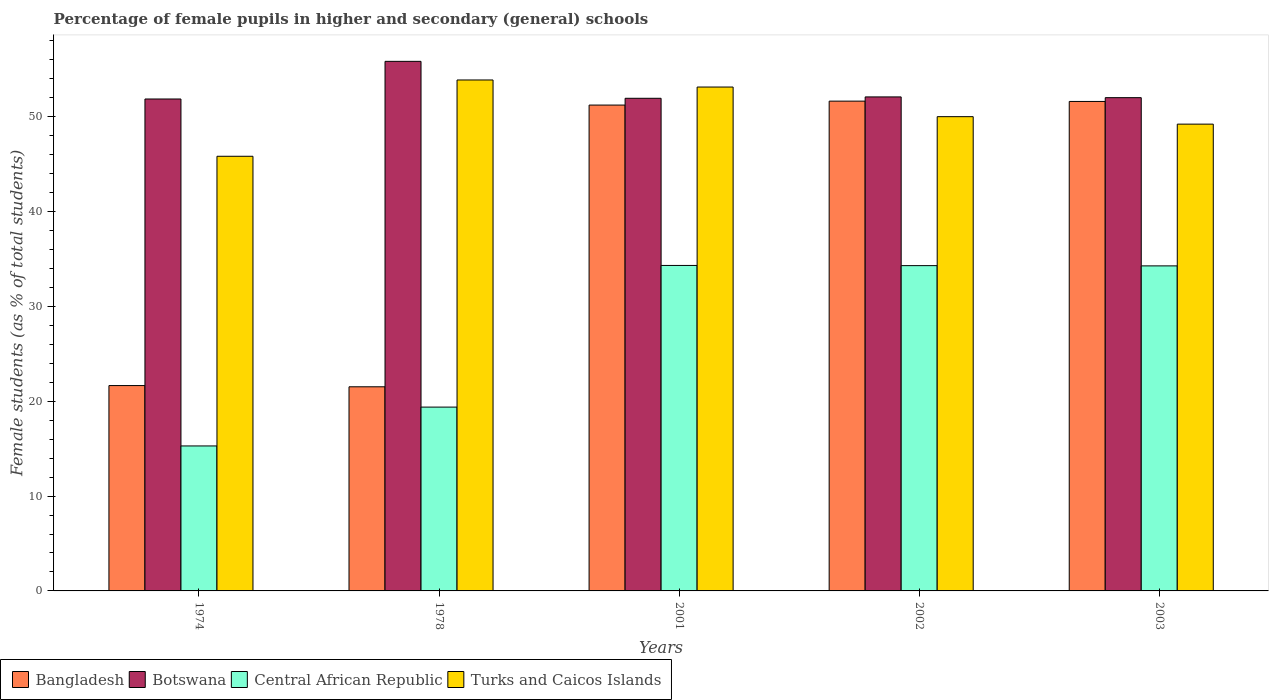Are the number of bars on each tick of the X-axis equal?
Make the answer very short. Yes. How many bars are there on the 2nd tick from the left?
Make the answer very short. 4. What is the label of the 4th group of bars from the left?
Provide a short and direct response. 2002. In how many cases, is the number of bars for a given year not equal to the number of legend labels?
Provide a short and direct response. 0. What is the percentage of female pupils in higher and secondary schools in Central African Republic in 1978?
Give a very brief answer. 19.38. Across all years, what is the maximum percentage of female pupils in higher and secondary schools in Turks and Caicos Islands?
Your response must be concise. 53.87. Across all years, what is the minimum percentage of female pupils in higher and secondary schools in Turks and Caicos Islands?
Keep it short and to the point. 45.82. In which year was the percentage of female pupils in higher and secondary schools in Bangladesh maximum?
Ensure brevity in your answer.  2002. In which year was the percentage of female pupils in higher and secondary schools in Bangladesh minimum?
Offer a terse response. 1978. What is the total percentage of female pupils in higher and secondary schools in Turks and Caicos Islands in the graph?
Offer a terse response. 252.03. What is the difference between the percentage of female pupils in higher and secondary schools in Turks and Caicos Islands in 2001 and that in 2002?
Your answer should be compact. 3.12. What is the difference between the percentage of female pupils in higher and secondary schools in Turks and Caicos Islands in 2003 and the percentage of female pupils in higher and secondary schools in Bangladesh in 1978?
Make the answer very short. 27.69. What is the average percentage of female pupils in higher and secondary schools in Central African Republic per year?
Keep it short and to the point. 27.51. In the year 2002, what is the difference between the percentage of female pupils in higher and secondary schools in Central African Republic and percentage of female pupils in higher and secondary schools in Turks and Caicos Islands?
Your answer should be compact. -15.71. What is the ratio of the percentage of female pupils in higher and secondary schools in Central African Republic in 1974 to that in 2002?
Give a very brief answer. 0.45. What is the difference between the highest and the second highest percentage of female pupils in higher and secondary schools in Bangladesh?
Offer a terse response. 0.03. What is the difference between the highest and the lowest percentage of female pupils in higher and secondary schools in Central African Republic?
Provide a succinct answer. 19.03. Is it the case that in every year, the sum of the percentage of female pupils in higher and secondary schools in Turks and Caicos Islands and percentage of female pupils in higher and secondary schools in Botswana is greater than the sum of percentage of female pupils in higher and secondary schools in Bangladesh and percentage of female pupils in higher and secondary schools in Central African Republic?
Give a very brief answer. No. What does the 2nd bar from the left in 2002 represents?
Your response must be concise. Botswana. What does the 2nd bar from the right in 2002 represents?
Offer a very short reply. Central African Republic. How many years are there in the graph?
Provide a succinct answer. 5. What is the difference between two consecutive major ticks on the Y-axis?
Your answer should be compact. 10. Does the graph contain any zero values?
Provide a short and direct response. No. Where does the legend appear in the graph?
Your answer should be compact. Bottom left. How many legend labels are there?
Provide a short and direct response. 4. What is the title of the graph?
Ensure brevity in your answer.  Percentage of female pupils in higher and secondary (general) schools. Does "Hungary" appear as one of the legend labels in the graph?
Keep it short and to the point. No. What is the label or title of the X-axis?
Provide a succinct answer. Years. What is the label or title of the Y-axis?
Offer a terse response. Female students (as % of total students). What is the Female students (as % of total students) in Bangladesh in 1974?
Offer a very short reply. 21.65. What is the Female students (as % of total students) in Botswana in 1974?
Keep it short and to the point. 51.86. What is the Female students (as % of total students) of Central African Republic in 1974?
Provide a succinct answer. 15.28. What is the Female students (as % of total students) of Turks and Caicos Islands in 1974?
Provide a succinct answer. 45.82. What is the Female students (as % of total students) in Bangladesh in 1978?
Your answer should be compact. 21.52. What is the Female students (as % of total students) of Botswana in 1978?
Make the answer very short. 55.83. What is the Female students (as % of total students) in Central African Republic in 1978?
Ensure brevity in your answer.  19.38. What is the Female students (as % of total students) of Turks and Caicos Islands in 1978?
Your answer should be compact. 53.87. What is the Female students (as % of total students) in Bangladesh in 2001?
Your response must be concise. 51.22. What is the Female students (as % of total students) of Botswana in 2001?
Your answer should be very brief. 51.94. What is the Female students (as % of total students) of Central African Republic in 2001?
Give a very brief answer. 34.31. What is the Female students (as % of total students) in Turks and Caicos Islands in 2001?
Your answer should be very brief. 53.12. What is the Female students (as % of total students) of Bangladesh in 2002?
Ensure brevity in your answer.  51.64. What is the Female students (as % of total students) of Botswana in 2002?
Provide a short and direct response. 52.08. What is the Female students (as % of total students) of Central African Republic in 2002?
Make the answer very short. 34.29. What is the Female students (as % of total students) of Bangladesh in 2003?
Keep it short and to the point. 51.6. What is the Female students (as % of total students) of Botswana in 2003?
Keep it short and to the point. 52. What is the Female students (as % of total students) of Central African Republic in 2003?
Provide a short and direct response. 34.27. What is the Female students (as % of total students) of Turks and Caicos Islands in 2003?
Your answer should be very brief. 49.21. Across all years, what is the maximum Female students (as % of total students) of Bangladesh?
Offer a terse response. 51.64. Across all years, what is the maximum Female students (as % of total students) of Botswana?
Provide a short and direct response. 55.83. Across all years, what is the maximum Female students (as % of total students) of Central African Republic?
Your response must be concise. 34.31. Across all years, what is the maximum Female students (as % of total students) in Turks and Caicos Islands?
Offer a very short reply. 53.87. Across all years, what is the minimum Female students (as % of total students) of Bangladesh?
Give a very brief answer. 21.52. Across all years, what is the minimum Female students (as % of total students) of Botswana?
Your response must be concise. 51.86. Across all years, what is the minimum Female students (as % of total students) of Central African Republic?
Your answer should be very brief. 15.28. Across all years, what is the minimum Female students (as % of total students) of Turks and Caicos Islands?
Make the answer very short. 45.82. What is the total Female students (as % of total students) in Bangladesh in the graph?
Keep it short and to the point. 197.63. What is the total Female students (as % of total students) in Botswana in the graph?
Give a very brief answer. 263.72. What is the total Female students (as % of total students) of Central African Republic in the graph?
Your response must be concise. 137.54. What is the total Female students (as % of total students) of Turks and Caicos Islands in the graph?
Your answer should be compact. 252.03. What is the difference between the Female students (as % of total students) in Bangladesh in 1974 and that in 1978?
Your answer should be very brief. 0.13. What is the difference between the Female students (as % of total students) in Botswana in 1974 and that in 1978?
Provide a short and direct response. -3.97. What is the difference between the Female students (as % of total students) of Central African Republic in 1974 and that in 1978?
Offer a terse response. -4.09. What is the difference between the Female students (as % of total students) of Turks and Caicos Islands in 1974 and that in 1978?
Offer a very short reply. -8.04. What is the difference between the Female students (as % of total students) of Bangladesh in 1974 and that in 2001?
Offer a terse response. -29.57. What is the difference between the Female students (as % of total students) in Botswana in 1974 and that in 2001?
Your answer should be compact. -0.08. What is the difference between the Female students (as % of total students) of Central African Republic in 1974 and that in 2001?
Offer a very short reply. -19.03. What is the difference between the Female students (as % of total students) of Turks and Caicos Islands in 1974 and that in 2001?
Your answer should be compact. -7.3. What is the difference between the Female students (as % of total students) of Bangladesh in 1974 and that in 2002?
Offer a very short reply. -29.99. What is the difference between the Female students (as % of total students) of Botswana in 1974 and that in 2002?
Provide a short and direct response. -0.22. What is the difference between the Female students (as % of total students) in Central African Republic in 1974 and that in 2002?
Ensure brevity in your answer.  -19.01. What is the difference between the Female students (as % of total students) of Turks and Caicos Islands in 1974 and that in 2002?
Keep it short and to the point. -4.18. What is the difference between the Female students (as % of total students) of Bangladesh in 1974 and that in 2003?
Provide a succinct answer. -29.95. What is the difference between the Female students (as % of total students) in Botswana in 1974 and that in 2003?
Offer a very short reply. -0.14. What is the difference between the Female students (as % of total students) of Central African Republic in 1974 and that in 2003?
Keep it short and to the point. -18.98. What is the difference between the Female students (as % of total students) of Turks and Caicos Islands in 1974 and that in 2003?
Offer a terse response. -3.39. What is the difference between the Female students (as % of total students) of Bangladesh in 1978 and that in 2001?
Offer a terse response. -29.7. What is the difference between the Female students (as % of total students) in Botswana in 1978 and that in 2001?
Provide a short and direct response. 3.89. What is the difference between the Female students (as % of total students) in Central African Republic in 1978 and that in 2001?
Your answer should be compact. -14.94. What is the difference between the Female students (as % of total students) of Turks and Caicos Islands in 1978 and that in 2001?
Ensure brevity in your answer.  0.75. What is the difference between the Female students (as % of total students) in Bangladesh in 1978 and that in 2002?
Your answer should be compact. -30.12. What is the difference between the Female students (as % of total students) of Botswana in 1978 and that in 2002?
Make the answer very short. 3.75. What is the difference between the Female students (as % of total students) in Central African Republic in 1978 and that in 2002?
Make the answer very short. -14.92. What is the difference between the Female students (as % of total students) in Turks and Caicos Islands in 1978 and that in 2002?
Your response must be concise. 3.87. What is the difference between the Female students (as % of total students) of Bangladesh in 1978 and that in 2003?
Provide a succinct answer. -30.08. What is the difference between the Female students (as % of total students) in Botswana in 1978 and that in 2003?
Your answer should be very brief. 3.83. What is the difference between the Female students (as % of total students) in Central African Republic in 1978 and that in 2003?
Provide a short and direct response. -14.89. What is the difference between the Female students (as % of total students) in Turks and Caicos Islands in 1978 and that in 2003?
Keep it short and to the point. 4.66. What is the difference between the Female students (as % of total students) of Bangladesh in 2001 and that in 2002?
Offer a terse response. -0.42. What is the difference between the Female students (as % of total students) in Botswana in 2001 and that in 2002?
Offer a very short reply. -0.14. What is the difference between the Female students (as % of total students) in Central African Republic in 2001 and that in 2002?
Provide a short and direct response. 0.02. What is the difference between the Female students (as % of total students) of Turks and Caicos Islands in 2001 and that in 2002?
Ensure brevity in your answer.  3.12. What is the difference between the Female students (as % of total students) of Bangladesh in 2001 and that in 2003?
Ensure brevity in your answer.  -0.38. What is the difference between the Female students (as % of total students) of Botswana in 2001 and that in 2003?
Your answer should be very brief. -0.07. What is the difference between the Female students (as % of total students) of Central African Republic in 2001 and that in 2003?
Keep it short and to the point. 0.05. What is the difference between the Female students (as % of total students) of Turks and Caicos Islands in 2001 and that in 2003?
Your answer should be compact. 3.91. What is the difference between the Female students (as % of total students) of Bangladesh in 2002 and that in 2003?
Keep it short and to the point. 0.03. What is the difference between the Female students (as % of total students) of Botswana in 2002 and that in 2003?
Your answer should be compact. 0.08. What is the difference between the Female students (as % of total students) of Central African Republic in 2002 and that in 2003?
Provide a succinct answer. 0.03. What is the difference between the Female students (as % of total students) in Turks and Caicos Islands in 2002 and that in 2003?
Make the answer very short. 0.79. What is the difference between the Female students (as % of total students) of Bangladesh in 1974 and the Female students (as % of total students) of Botswana in 1978?
Keep it short and to the point. -34.18. What is the difference between the Female students (as % of total students) of Bangladesh in 1974 and the Female students (as % of total students) of Central African Republic in 1978?
Your answer should be very brief. 2.27. What is the difference between the Female students (as % of total students) of Bangladesh in 1974 and the Female students (as % of total students) of Turks and Caicos Islands in 1978?
Provide a short and direct response. -32.22. What is the difference between the Female students (as % of total students) of Botswana in 1974 and the Female students (as % of total students) of Central African Republic in 1978?
Your answer should be compact. 32.48. What is the difference between the Female students (as % of total students) of Botswana in 1974 and the Female students (as % of total students) of Turks and Caicos Islands in 1978?
Provide a short and direct response. -2.01. What is the difference between the Female students (as % of total students) of Central African Republic in 1974 and the Female students (as % of total students) of Turks and Caicos Islands in 1978?
Your answer should be compact. -38.58. What is the difference between the Female students (as % of total students) in Bangladesh in 1974 and the Female students (as % of total students) in Botswana in 2001?
Your response must be concise. -30.29. What is the difference between the Female students (as % of total students) in Bangladesh in 1974 and the Female students (as % of total students) in Central African Republic in 2001?
Offer a very short reply. -12.66. What is the difference between the Female students (as % of total students) of Bangladesh in 1974 and the Female students (as % of total students) of Turks and Caicos Islands in 2001?
Ensure brevity in your answer.  -31.47. What is the difference between the Female students (as % of total students) in Botswana in 1974 and the Female students (as % of total students) in Central African Republic in 2001?
Give a very brief answer. 17.55. What is the difference between the Female students (as % of total students) in Botswana in 1974 and the Female students (as % of total students) in Turks and Caicos Islands in 2001?
Give a very brief answer. -1.26. What is the difference between the Female students (as % of total students) of Central African Republic in 1974 and the Female students (as % of total students) of Turks and Caicos Islands in 2001?
Offer a very short reply. -37.84. What is the difference between the Female students (as % of total students) of Bangladesh in 1974 and the Female students (as % of total students) of Botswana in 2002?
Ensure brevity in your answer.  -30.43. What is the difference between the Female students (as % of total students) of Bangladesh in 1974 and the Female students (as % of total students) of Central African Republic in 2002?
Keep it short and to the point. -12.64. What is the difference between the Female students (as % of total students) of Bangladesh in 1974 and the Female students (as % of total students) of Turks and Caicos Islands in 2002?
Your response must be concise. -28.35. What is the difference between the Female students (as % of total students) of Botswana in 1974 and the Female students (as % of total students) of Central African Republic in 2002?
Ensure brevity in your answer.  17.57. What is the difference between the Female students (as % of total students) in Botswana in 1974 and the Female students (as % of total students) in Turks and Caicos Islands in 2002?
Provide a succinct answer. 1.86. What is the difference between the Female students (as % of total students) of Central African Republic in 1974 and the Female students (as % of total students) of Turks and Caicos Islands in 2002?
Ensure brevity in your answer.  -34.72. What is the difference between the Female students (as % of total students) of Bangladesh in 1974 and the Female students (as % of total students) of Botswana in 2003?
Provide a succinct answer. -30.35. What is the difference between the Female students (as % of total students) in Bangladesh in 1974 and the Female students (as % of total students) in Central African Republic in 2003?
Provide a short and direct response. -12.62. What is the difference between the Female students (as % of total students) of Bangladesh in 1974 and the Female students (as % of total students) of Turks and Caicos Islands in 2003?
Your response must be concise. -27.56. What is the difference between the Female students (as % of total students) in Botswana in 1974 and the Female students (as % of total students) in Central African Republic in 2003?
Make the answer very short. 17.59. What is the difference between the Female students (as % of total students) of Botswana in 1974 and the Female students (as % of total students) of Turks and Caicos Islands in 2003?
Your answer should be compact. 2.65. What is the difference between the Female students (as % of total students) in Central African Republic in 1974 and the Female students (as % of total students) in Turks and Caicos Islands in 2003?
Your answer should be very brief. -33.93. What is the difference between the Female students (as % of total students) of Bangladesh in 1978 and the Female students (as % of total students) of Botswana in 2001?
Ensure brevity in your answer.  -30.42. What is the difference between the Female students (as % of total students) of Bangladesh in 1978 and the Female students (as % of total students) of Central African Republic in 2001?
Provide a short and direct response. -12.79. What is the difference between the Female students (as % of total students) in Bangladesh in 1978 and the Female students (as % of total students) in Turks and Caicos Islands in 2001?
Give a very brief answer. -31.6. What is the difference between the Female students (as % of total students) in Botswana in 1978 and the Female students (as % of total students) in Central African Republic in 2001?
Offer a terse response. 21.52. What is the difference between the Female students (as % of total students) in Botswana in 1978 and the Female students (as % of total students) in Turks and Caicos Islands in 2001?
Your response must be concise. 2.71. What is the difference between the Female students (as % of total students) of Central African Republic in 1978 and the Female students (as % of total students) of Turks and Caicos Islands in 2001?
Your answer should be compact. -33.74. What is the difference between the Female students (as % of total students) of Bangladesh in 1978 and the Female students (as % of total students) of Botswana in 2002?
Your response must be concise. -30.56. What is the difference between the Female students (as % of total students) in Bangladesh in 1978 and the Female students (as % of total students) in Central African Republic in 2002?
Make the answer very short. -12.77. What is the difference between the Female students (as % of total students) of Bangladesh in 1978 and the Female students (as % of total students) of Turks and Caicos Islands in 2002?
Keep it short and to the point. -28.48. What is the difference between the Female students (as % of total students) in Botswana in 1978 and the Female students (as % of total students) in Central African Republic in 2002?
Keep it short and to the point. 21.54. What is the difference between the Female students (as % of total students) in Botswana in 1978 and the Female students (as % of total students) in Turks and Caicos Islands in 2002?
Your answer should be compact. 5.83. What is the difference between the Female students (as % of total students) of Central African Republic in 1978 and the Female students (as % of total students) of Turks and Caicos Islands in 2002?
Ensure brevity in your answer.  -30.62. What is the difference between the Female students (as % of total students) in Bangladesh in 1978 and the Female students (as % of total students) in Botswana in 2003?
Provide a short and direct response. -30.48. What is the difference between the Female students (as % of total students) of Bangladesh in 1978 and the Female students (as % of total students) of Central African Republic in 2003?
Give a very brief answer. -12.75. What is the difference between the Female students (as % of total students) in Bangladesh in 1978 and the Female students (as % of total students) in Turks and Caicos Islands in 2003?
Your answer should be compact. -27.69. What is the difference between the Female students (as % of total students) of Botswana in 1978 and the Female students (as % of total students) of Central African Republic in 2003?
Your response must be concise. 21.56. What is the difference between the Female students (as % of total students) of Botswana in 1978 and the Female students (as % of total students) of Turks and Caicos Islands in 2003?
Offer a terse response. 6.62. What is the difference between the Female students (as % of total students) in Central African Republic in 1978 and the Female students (as % of total students) in Turks and Caicos Islands in 2003?
Offer a very short reply. -29.83. What is the difference between the Female students (as % of total students) of Bangladesh in 2001 and the Female students (as % of total students) of Botswana in 2002?
Provide a succinct answer. -0.86. What is the difference between the Female students (as % of total students) in Bangladesh in 2001 and the Female students (as % of total students) in Central African Republic in 2002?
Provide a short and direct response. 16.93. What is the difference between the Female students (as % of total students) of Bangladesh in 2001 and the Female students (as % of total students) of Turks and Caicos Islands in 2002?
Keep it short and to the point. 1.22. What is the difference between the Female students (as % of total students) of Botswana in 2001 and the Female students (as % of total students) of Central African Republic in 2002?
Your answer should be very brief. 17.64. What is the difference between the Female students (as % of total students) in Botswana in 2001 and the Female students (as % of total students) in Turks and Caicos Islands in 2002?
Keep it short and to the point. 1.94. What is the difference between the Female students (as % of total students) in Central African Republic in 2001 and the Female students (as % of total students) in Turks and Caicos Islands in 2002?
Provide a short and direct response. -15.69. What is the difference between the Female students (as % of total students) of Bangladesh in 2001 and the Female students (as % of total students) of Botswana in 2003?
Ensure brevity in your answer.  -0.78. What is the difference between the Female students (as % of total students) in Bangladesh in 2001 and the Female students (as % of total students) in Central African Republic in 2003?
Offer a very short reply. 16.95. What is the difference between the Female students (as % of total students) in Bangladesh in 2001 and the Female students (as % of total students) in Turks and Caicos Islands in 2003?
Make the answer very short. 2.01. What is the difference between the Female students (as % of total students) in Botswana in 2001 and the Female students (as % of total students) in Central African Republic in 2003?
Provide a succinct answer. 17.67. What is the difference between the Female students (as % of total students) of Botswana in 2001 and the Female students (as % of total students) of Turks and Caicos Islands in 2003?
Make the answer very short. 2.73. What is the difference between the Female students (as % of total students) of Central African Republic in 2001 and the Female students (as % of total students) of Turks and Caicos Islands in 2003?
Offer a very short reply. -14.9. What is the difference between the Female students (as % of total students) in Bangladesh in 2002 and the Female students (as % of total students) in Botswana in 2003?
Keep it short and to the point. -0.37. What is the difference between the Female students (as % of total students) of Bangladesh in 2002 and the Female students (as % of total students) of Central African Republic in 2003?
Ensure brevity in your answer.  17.37. What is the difference between the Female students (as % of total students) in Bangladesh in 2002 and the Female students (as % of total students) in Turks and Caicos Islands in 2003?
Provide a succinct answer. 2.42. What is the difference between the Female students (as % of total students) in Botswana in 2002 and the Female students (as % of total students) in Central African Republic in 2003?
Give a very brief answer. 17.81. What is the difference between the Female students (as % of total students) of Botswana in 2002 and the Female students (as % of total students) of Turks and Caicos Islands in 2003?
Keep it short and to the point. 2.87. What is the difference between the Female students (as % of total students) of Central African Republic in 2002 and the Female students (as % of total students) of Turks and Caicos Islands in 2003?
Provide a succinct answer. -14.92. What is the average Female students (as % of total students) in Bangladesh per year?
Your answer should be very brief. 39.53. What is the average Female students (as % of total students) of Botswana per year?
Keep it short and to the point. 52.74. What is the average Female students (as % of total students) of Central African Republic per year?
Ensure brevity in your answer.  27.51. What is the average Female students (as % of total students) of Turks and Caicos Islands per year?
Keep it short and to the point. 50.41. In the year 1974, what is the difference between the Female students (as % of total students) of Bangladesh and Female students (as % of total students) of Botswana?
Offer a terse response. -30.21. In the year 1974, what is the difference between the Female students (as % of total students) in Bangladesh and Female students (as % of total students) in Central African Republic?
Your answer should be very brief. 6.37. In the year 1974, what is the difference between the Female students (as % of total students) of Bangladesh and Female students (as % of total students) of Turks and Caicos Islands?
Keep it short and to the point. -24.17. In the year 1974, what is the difference between the Female students (as % of total students) in Botswana and Female students (as % of total students) in Central African Republic?
Offer a terse response. 36.58. In the year 1974, what is the difference between the Female students (as % of total students) in Botswana and Female students (as % of total students) in Turks and Caicos Islands?
Offer a terse response. 6.04. In the year 1974, what is the difference between the Female students (as % of total students) of Central African Republic and Female students (as % of total students) of Turks and Caicos Islands?
Offer a very short reply. -30.54. In the year 1978, what is the difference between the Female students (as % of total students) in Bangladesh and Female students (as % of total students) in Botswana?
Make the answer very short. -34.31. In the year 1978, what is the difference between the Female students (as % of total students) of Bangladesh and Female students (as % of total students) of Central African Republic?
Provide a succinct answer. 2.14. In the year 1978, what is the difference between the Female students (as % of total students) in Bangladesh and Female students (as % of total students) in Turks and Caicos Islands?
Your response must be concise. -32.35. In the year 1978, what is the difference between the Female students (as % of total students) of Botswana and Female students (as % of total students) of Central African Republic?
Offer a terse response. 36.45. In the year 1978, what is the difference between the Female students (as % of total students) of Botswana and Female students (as % of total students) of Turks and Caicos Islands?
Offer a very short reply. 1.96. In the year 1978, what is the difference between the Female students (as % of total students) of Central African Republic and Female students (as % of total students) of Turks and Caicos Islands?
Your answer should be very brief. -34.49. In the year 2001, what is the difference between the Female students (as % of total students) in Bangladesh and Female students (as % of total students) in Botswana?
Your answer should be very brief. -0.72. In the year 2001, what is the difference between the Female students (as % of total students) in Bangladesh and Female students (as % of total students) in Central African Republic?
Make the answer very short. 16.91. In the year 2001, what is the difference between the Female students (as % of total students) in Bangladesh and Female students (as % of total students) in Turks and Caicos Islands?
Ensure brevity in your answer.  -1.9. In the year 2001, what is the difference between the Female students (as % of total students) in Botswana and Female students (as % of total students) in Central African Republic?
Your answer should be very brief. 17.62. In the year 2001, what is the difference between the Female students (as % of total students) of Botswana and Female students (as % of total students) of Turks and Caicos Islands?
Your answer should be very brief. -1.18. In the year 2001, what is the difference between the Female students (as % of total students) in Central African Republic and Female students (as % of total students) in Turks and Caicos Islands?
Your response must be concise. -18.81. In the year 2002, what is the difference between the Female students (as % of total students) of Bangladesh and Female students (as % of total students) of Botswana?
Make the answer very short. -0.44. In the year 2002, what is the difference between the Female students (as % of total students) in Bangladesh and Female students (as % of total students) in Central African Republic?
Offer a terse response. 17.34. In the year 2002, what is the difference between the Female students (as % of total students) of Bangladesh and Female students (as % of total students) of Turks and Caicos Islands?
Offer a very short reply. 1.64. In the year 2002, what is the difference between the Female students (as % of total students) in Botswana and Female students (as % of total students) in Central African Republic?
Give a very brief answer. 17.79. In the year 2002, what is the difference between the Female students (as % of total students) in Botswana and Female students (as % of total students) in Turks and Caicos Islands?
Provide a succinct answer. 2.08. In the year 2002, what is the difference between the Female students (as % of total students) of Central African Republic and Female students (as % of total students) of Turks and Caicos Islands?
Your answer should be very brief. -15.71. In the year 2003, what is the difference between the Female students (as % of total students) of Bangladesh and Female students (as % of total students) of Botswana?
Offer a terse response. -0.4. In the year 2003, what is the difference between the Female students (as % of total students) of Bangladesh and Female students (as % of total students) of Central African Republic?
Your response must be concise. 17.34. In the year 2003, what is the difference between the Female students (as % of total students) of Bangladesh and Female students (as % of total students) of Turks and Caicos Islands?
Make the answer very short. 2.39. In the year 2003, what is the difference between the Female students (as % of total students) in Botswana and Female students (as % of total students) in Central African Republic?
Offer a terse response. 17.73. In the year 2003, what is the difference between the Female students (as % of total students) of Botswana and Female students (as % of total students) of Turks and Caicos Islands?
Keep it short and to the point. 2.79. In the year 2003, what is the difference between the Female students (as % of total students) of Central African Republic and Female students (as % of total students) of Turks and Caicos Islands?
Provide a succinct answer. -14.94. What is the ratio of the Female students (as % of total students) in Bangladesh in 1974 to that in 1978?
Make the answer very short. 1.01. What is the ratio of the Female students (as % of total students) of Botswana in 1974 to that in 1978?
Offer a very short reply. 0.93. What is the ratio of the Female students (as % of total students) of Central African Republic in 1974 to that in 1978?
Give a very brief answer. 0.79. What is the ratio of the Female students (as % of total students) of Turks and Caicos Islands in 1974 to that in 1978?
Your answer should be very brief. 0.85. What is the ratio of the Female students (as % of total students) of Bangladesh in 1974 to that in 2001?
Your response must be concise. 0.42. What is the ratio of the Female students (as % of total students) of Botswana in 1974 to that in 2001?
Offer a very short reply. 1. What is the ratio of the Female students (as % of total students) of Central African Republic in 1974 to that in 2001?
Offer a terse response. 0.45. What is the ratio of the Female students (as % of total students) of Turks and Caicos Islands in 1974 to that in 2001?
Ensure brevity in your answer.  0.86. What is the ratio of the Female students (as % of total students) of Bangladesh in 1974 to that in 2002?
Give a very brief answer. 0.42. What is the ratio of the Female students (as % of total students) in Botswana in 1974 to that in 2002?
Give a very brief answer. 1. What is the ratio of the Female students (as % of total students) in Central African Republic in 1974 to that in 2002?
Keep it short and to the point. 0.45. What is the ratio of the Female students (as % of total students) of Turks and Caicos Islands in 1974 to that in 2002?
Offer a very short reply. 0.92. What is the ratio of the Female students (as % of total students) of Bangladesh in 1974 to that in 2003?
Offer a terse response. 0.42. What is the ratio of the Female students (as % of total students) in Central African Republic in 1974 to that in 2003?
Give a very brief answer. 0.45. What is the ratio of the Female students (as % of total students) in Turks and Caicos Islands in 1974 to that in 2003?
Offer a terse response. 0.93. What is the ratio of the Female students (as % of total students) of Bangladesh in 1978 to that in 2001?
Keep it short and to the point. 0.42. What is the ratio of the Female students (as % of total students) of Botswana in 1978 to that in 2001?
Make the answer very short. 1.07. What is the ratio of the Female students (as % of total students) of Central African Republic in 1978 to that in 2001?
Your answer should be compact. 0.56. What is the ratio of the Female students (as % of total students) in Turks and Caicos Islands in 1978 to that in 2001?
Your answer should be very brief. 1.01. What is the ratio of the Female students (as % of total students) in Bangladesh in 1978 to that in 2002?
Provide a succinct answer. 0.42. What is the ratio of the Female students (as % of total students) of Botswana in 1978 to that in 2002?
Make the answer very short. 1.07. What is the ratio of the Female students (as % of total students) in Central African Republic in 1978 to that in 2002?
Offer a very short reply. 0.57. What is the ratio of the Female students (as % of total students) in Turks and Caicos Islands in 1978 to that in 2002?
Your answer should be very brief. 1.08. What is the ratio of the Female students (as % of total students) in Bangladesh in 1978 to that in 2003?
Your answer should be compact. 0.42. What is the ratio of the Female students (as % of total students) of Botswana in 1978 to that in 2003?
Make the answer very short. 1.07. What is the ratio of the Female students (as % of total students) of Central African Republic in 1978 to that in 2003?
Keep it short and to the point. 0.57. What is the ratio of the Female students (as % of total students) of Turks and Caicos Islands in 1978 to that in 2003?
Offer a very short reply. 1.09. What is the ratio of the Female students (as % of total students) in Bangladesh in 2001 to that in 2002?
Offer a very short reply. 0.99. What is the ratio of the Female students (as % of total students) in Botswana in 2001 to that in 2002?
Your answer should be very brief. 1. What is the ratio of the Female students (as % of total students) in Turks and Caicos Islands in 2001 to that in 2002?
Offer a terse response. 1.06. What is the ratio of the Female students (as % of total students) in Turks and Caicos Islands in 2001 to that in 2003?
Keep it short and to the point. 1.08. What is the ratio of the Female students (as % of total students) of Bangladesh in 2002 to that in 2003?
Offer a terse response. 1. What is the ratio of the Female students (as % of total students) in Botswana in 2002 to that in 2003?
Your answer should be compact. 1. What is the ratio of the Female students (as % of total students) of Central African Republic in 2002 to that in 2003?
Make the answer very short. 1. What is the difference between the highest and the second highest Female students (as % of total students) in Bangladesh?
Provide a succinct answer. 0.03. What is the difference between the highest and the second highest Female students (as % of total students) of Botswana?
Provide a succinct answer. 3.75. What is the difference between the highest and the second highest Female students (as % of total students) in Central African Republic?
Offer a very short reply. 0.02. What is the difference between the highest and the second highest Female students (as % of total students) of Turks and Caicos Islands?
Your response must be concise. 0.75. What is the difference between the highest and the lowest Female students (as % of total students) in Bangladesh?
Offer a terse response. 30.12. What is the difference between the highest and the lowest Female students (as % of total students) of Botswana?
Your response must be concise. 3.97. What is the difference between the highest and the lowest Female students (as % of total students) of Central African Republic?
Provide a short and direct response. 19.03. What is the difference between the highest and the lowest Female students (as % of total students) in Turks and Caicos Islands?
Give a very brief answer. 8.04. 